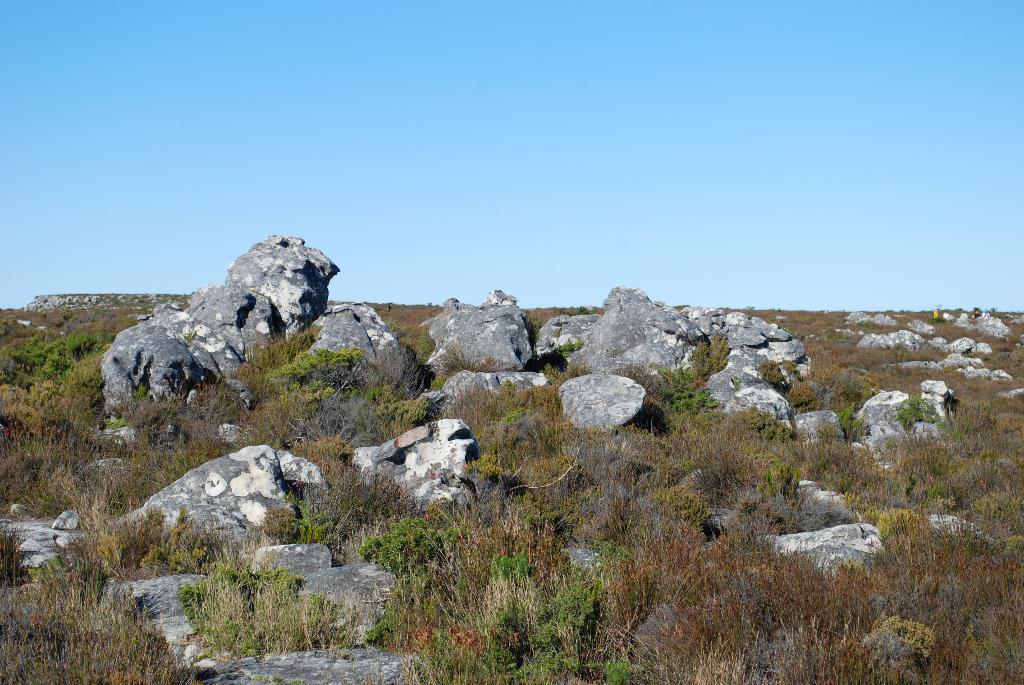Could you give a brief overview of what you see in this image? In this picture we can see few rocks and plants. 